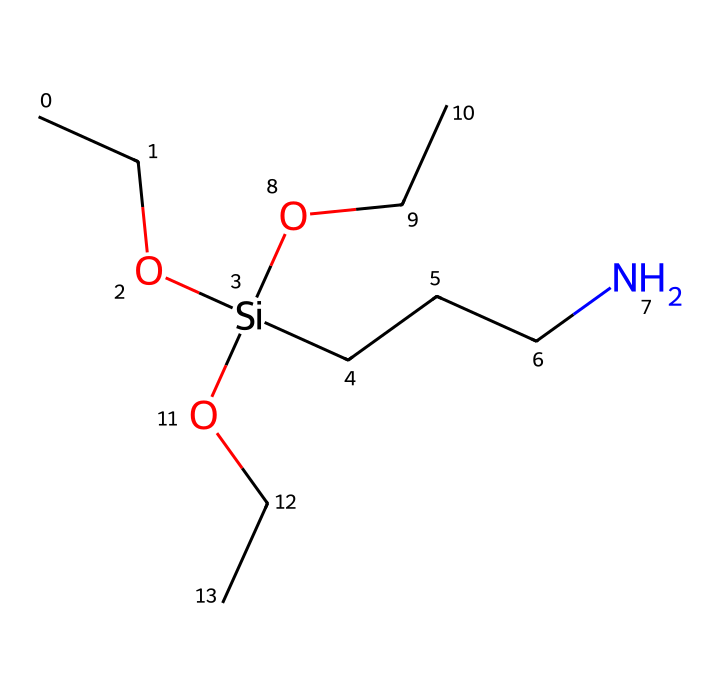What is the molecular formula of this silane? To determine the molecular formula, count the number of each type of atom in the chemical structure. In the provided SMILES, there are 12 carbon (C) atoms, 27 hydrogen (H) atoms, 1 oxygen (O) atom, and 1 silicon (Si) atom. Thus, the molecular formula is C12H27O1Si1.
Answer: C12H27OSi How many alkoxy groups are present in this silane? Reviewing the structure provided, the two -OCC groups indicate there are two alkoxy groups attached to the silicon atom. Alkoxy groups typically refer to -O-R structures where R is an alkyl group.
Answer: 2 What type of functional groups are present in this silane? In this chemical structure, the functional groups include alkoxy (-OCC) and amino (-NC) groups. Alkoxy is indicated by the -OCC portions and amino is represented by the -N- portion that connects to other alkyl chains.
Answer: alkoxy and amino How many total atoms are present in this silane? Counting all atoms in the structure, we see that there are 12 carbon atoms, 27 hydrogen atoms, 1 oxygen atom, and 1 silicon atom. Adding these up gives a total of 41 atoms in the molecule (12 + 27 + 1 + 1 = 41).
Answer: 41 What does the presence of silicon in this silane suggest about its application? The presence of silicon in this molecule indicates that it is a silane, typically used as a coupling agent in composite materials, enhancing adhesion between the paddle fibers and matrix resin for better structural integrity.
Answer: coupling agent What type of silane is represented by this structure? Given the multiple alkyl and alkoxy groups alongside the silicon atom, this structure represents an amino silane, which is characterized by the presence of an amine group that enhances bonding capabilities in composites.
Answer: amino silane 